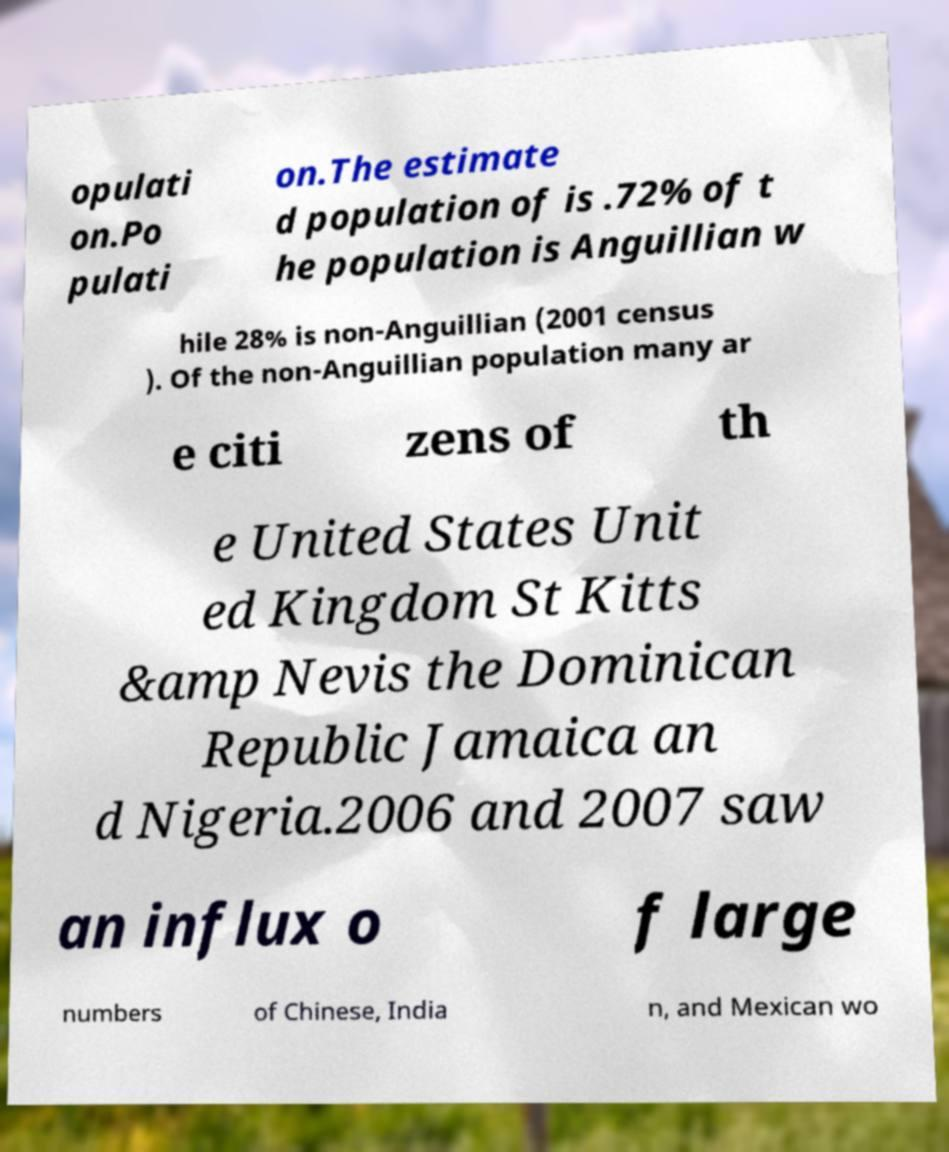Can you accurately transcribe the text from the provided image for me? opulati on.Po pulati on.The estimate d population of is .72% of t he population is Anguillian w hile 28% is non-Anguillian (2001 census ). Of the non-Anguillian population many ar e citi zens of th e United States Unit ed Kingdom St Kitts &amp Nevis the Dominican Republic Jamaica an d Nigeria.2006 and 2007 saw an influx o f large numbers of Chinese, India n, and Mexican wo 